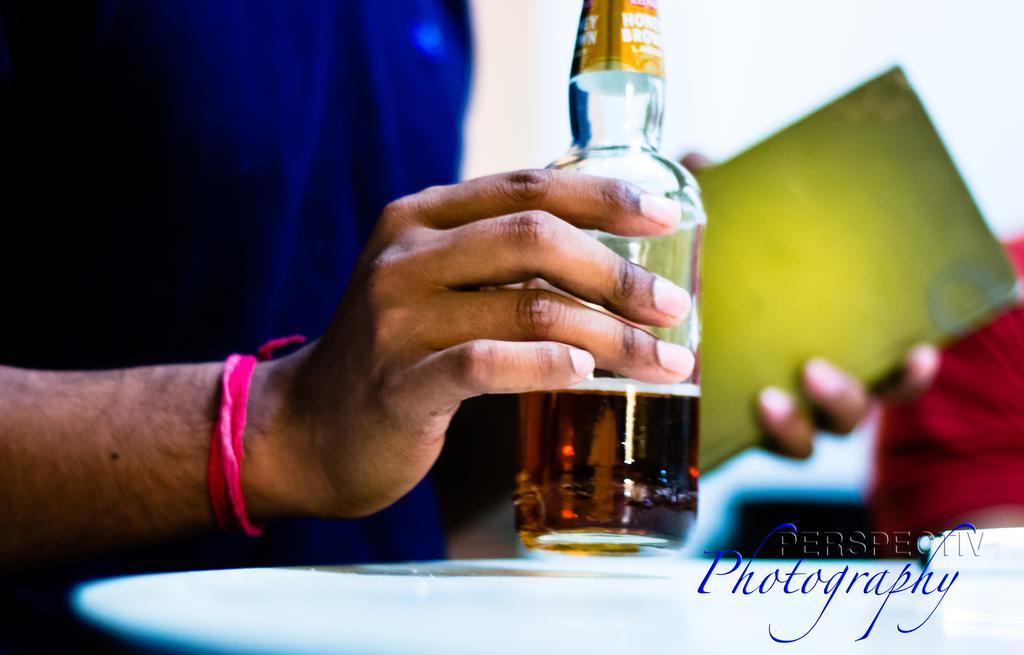<image>
Give a short and clear explanation of the subsequent image. the word photography that is on a photo 